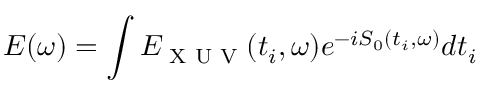<formula> <loc_0><loc_0><loc_500><loc_500>E ( \omega ) = \int E _ { X U V } ( t _ { i } , \omega ) e ^ { - i S _ { 0 } ( t _ { i } , \omega ) } d t _ { i }</formula> 